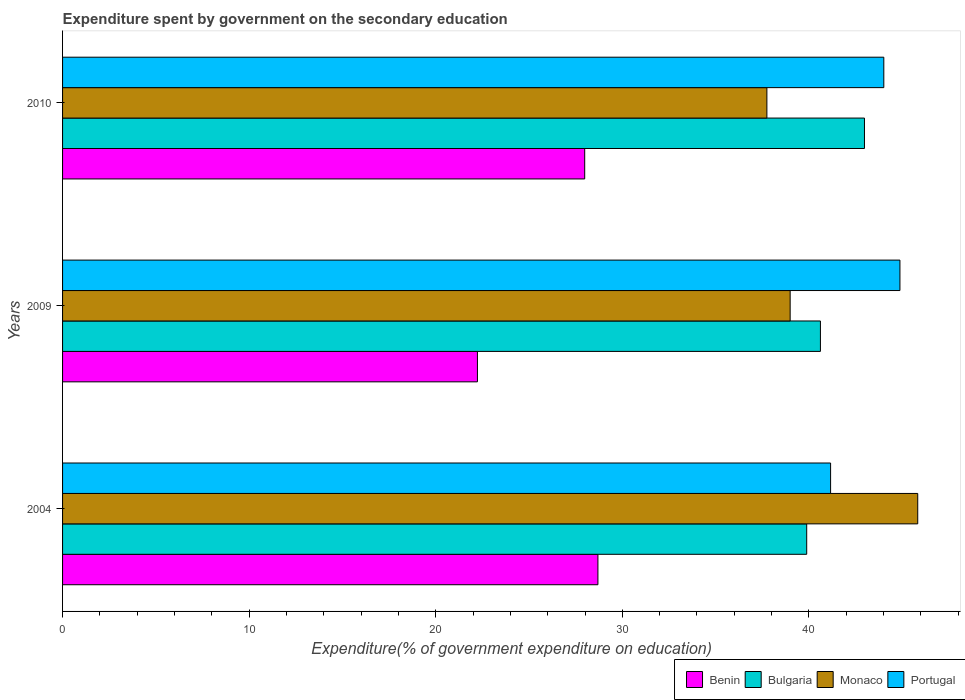How many groups of bars are there?
Your response must be concise. 3. Are the number of bars on each tick of the Y-axis equal?
Offer a terse response. Yes. How many bars are there on the 1st tick from the top?
Your answer should be compact. 4. What is the expenditure spent by government on the secondary education in Bulgaria in 2010?
Offer a terse response. 42.98. Across all years, what is the maximum expenditure spent by government on the secondary education in Bulgaria?
Your answer should be very brief. 42.98. Across all years, what is the minimum expenditure spent by government on the secondary education in Bulgaria?
Provide a succinct answer. 39.88. What is the total expenditure spent by government on the secondary education in Benin in the graph?
Offer a very short reply. 78.91. What is the difference between the expenditure spent by government on the secondary education in Monaco in 2004 and that in 2010?
Your answer should be very brief. 8.08. What is the difference between the expenditure spent by government on the secondary education in Portugal in 2010 and the expenditure spent by government on the secondary education in Bulgaria in 2009?
Your answer should be very brief. 3.4. What is the average expenditure spent by government on the secondary education in Benin per year?
Provide a short and direct response. 26.3. In the year 2009, what is the difference between the expenditure spent by government on the secondary education in Bulgaria and expenditure spent by government on the secondary education in Monaco?
Your response must be concise. 1.62. In how many years, is the expenditure spent by government on the secondary education in Benin greater than 12 %?
Make the answer very short. 3. What is the ratio of the expenditure spent by government on the secondary education in Bulgaria in 2009 to that in 2010?
Offer a terse response. 0.95. Is the expenditure spent by government on the secondary education in Portugal in 2004 less than that in 2010?
Offer a terse response. Yes. What is the difference between the highest and the second highest expenditure spent by government on the secondary education in Bulgaria?
Keep it short and to the point. 2.36. What is the difference between the highest and the lowest expenditure spent by government on the secondary education in Bulgaria?
Your answer should be very brief. 3.1. In how many years, is the expenditure spent by government on the secondary education in Benin greater than the average expenditure spent by government on the secondary education in Benin taken over all years?
Provide a short and direct response. 2. Is the sum of the expenditure spent by government on the secondary education in Bulgaria in 2004 and 2010 greater than the maximum expenditure spent by government on the secondary education in Benin across all years?
Provide a short and direct response. Yes. What does the 4th bar from the top in 2009 represents?
Offer a terse response. Benin. What does the 1st bar from the bottom in 2004 represents?
Your answer should be very brief. Benin. What is the difference between two consecutive major ticks on the X-axis?
Your answer should be compact. 10. Are the values on the major ticks of X-axis written in scientific E-notation?
Your answer should be very brief. No. Does the graph contain grids?
Make the answer very short. No. How many legend labels are there?
Keep it short and to the point. 4. How are the legend labels stacked?
Your answer should be very brief. Horizontal. What is the title of the graph?
Your answer should be compact. Expenditure spent by government on the secondary education. What is the label or title of the X-axis?
Make the answer very short. Expenditure(% of government expenditure on education). What is the Expenditure(% of government expenditure on education) of Benin in 2004?
Provide a succinct answer. 28.69. What is the Expenditure(% of government expenditure on education) in Bulgaria in 2004?
Ensure brevity in your answer.  39.88. What is the Expenditure(% of government expenditure on education) in Monaco in 2004?
Make the answer very short. 45.83. What is the Expenditure(% of government expenditure on education) of Portugal in 2004?
Your response must be concise. 41.16. What is the Expenditure(% of government expenditure on education) in Benin in 2009?
Your answer should be very brief. 22.23. What is the Expenditure(% of government expenditure on education) of Bulgaria in 2009?
Make the answer very short. 40.62. What is the Expenditure(% of government expenditure on education) of Monaco in 2009?
Provide a succinct answer. 38.99. What is the Expenditure(% of government expenditure on education) in Portugal in 2009?
Keep it short and to the point. 44.88. What is the Expenditure(% of government expenditure on education) of Benin in 2010?
Your answer should be very brief. 27.98. What is the Expenditure(% of government expenditure on education) in Bulgaria in 2010?
Your answer should be compact. 42.98. What is the Expenditure(% of government expenditure on education) in Monaco in 2010?
Offer a terse response. 37.75. What is the Expenditure(% of government expenditure on education) in Portugal in 2010?
Your answer should be very brief. 44.01. Across all years, what is the maximum Expenditure(% of government expenditure on education) of Benin?
Your answer should be compact. 28.69. Across all years, what is the maximum Expenditure(% of government expenditure on education) in Bulgaria?
Provide a short and direct response. 42.98. Across all years, what is the maximum Expenditure(% of government expenditure on education) in Monaco?
Provide a succinct answer. 45.83. Across all years, what is the maximum Expenditure(% of government expenditure on education) of Portugal?
Make the answer very short. 44.88. Across all years, what is the minimum Expenditure(% of government expenditure on education) of Benin?
Offer a very short reply. 22.23. Across all years, what is the minimum Expenditure(% of government expenditure on education) in Bulgaria?
Your answer should be very brief. 39.88. Across all years, what is the minimum Expenditure(% of government expenditure on education) of Monaco?
Keep it short and to the point. 37.75. Across all years, what is the minimum Expenditure(% of government expenditure on education) of Portugal?
Your answer should be very brief. 41.16. What is the total Expenditure(% of government expenditure on education) of Benin in the graph?
Your response must be concise. 78.91. What is the total Expenditure(% of government expenditure on education) of Bulgaria in the graph?
Ensure brevity in your answer.  123.47. What is the total Expenditure(% of government expenditure on education) in Monaco in the graph?
Provide a succinct answer. 122.57. What is the total Expenditure(% of government expenditure on education) in Portugal in the graph?
Offer a terse response. 130.05. What is the difference between the Expenditure(% of government expenditure on education) of Benin in 2004 and that in 2009?
Keep it short and to the point. 6.46. What is the difference between the Expenditure(% of government expenditure on education) in Bulgaria in 2004 and that in 2009?
Give a very brief answer. -0.74. What is the difference between the Expenditure(% of government expenditure on education) in Monaco in 2004 and that in 2009?
Keep it short and to the point. 6.84. What is the difference between the Expenditure(% of government expenditure on education) of Portugal in 2004 and that in 2009?
Your answer should be very brief. -3.72. What is the difference between the Expenditure(% of government expenditure on education) in Benin in 2004 and that in 2010?
Keep it short and to the point. 0.71. What is the difference between the Expenditure(% of government expenditure on education) of Bulgaria in 2004 and that in 2010?
Offer a terse response. -3.1. What is the difference between the Expenditure(% of government expenditure on education) of Monaco in 2004 and that in 2010?
Keep it short and to the point. 8.08. What is the difference between the Expenditure(% of government expenditure on education) in Portugal in 2004 and that in 2010?
Your response must be concise. -2.85. What is the difference between the Expenditure(% of government expenditure on education) in Benin in 2009 and that in 2010?
Your answer should be very brief. -5.75. What is the difference between the Expenditure(% of government expenditure on education) of Bulgaria in 2009 and that in 2010?
Keep it short and to the point. -2.36. What is the difference between the Expenditure(% of government expenditure on education) in Monaco in 2009 and that in 2010?
Provide a succinct answer. 1.25. What is the difference between the Expenditure(% of government expenditure on education) of Portugal in 2009 and that in 2010?
Offer a very short reply. 0.86. What is the difference between the Expenditure(% of government expenditure on education) in Benin in 2004 and the Expenditure(% of government expenditure on education) in Bulgaria in 2009?
Ensure brevity in your answer.  -11.93. What is the difference between the Expenditure(% of government expenditure on education) in Benin in 2004 and the Expenditure(% of government expenditure on education) in Monaco in 2009?
Give a very brief answer. -10.3. What is the difference between the Expenditure(% of government expenditure on education) in Benin in 2004 and the Expenditure(% of government expenditure on education) in Portugal in 2009?
Offer a terse response. -16.19. What is the difference between the Expenditure(% of government expenditure on education) in Bulgaria in 2004 and the Expenditure(% of government expenditure on education) in Monaco in 2009?
Make the answer very short. 0.89. What is the difference between the Expenditure(% of government expenditure on education) in Bulgaria in 2004 and the Expenditure(% of government expenditure on education) in Portugal in 2009?
Make the answer very short. -5. What is the difference between the Expenditure(% of government expenditure on education) of Monaco in 2004 and the Expenditure(% of government expenditure on education) of Portugal in 2009?
Make the answer very short. 0.95. What is the difference between the Expenditure(% of government expenditure on education) in Benin in 2004 and the Expenditure(% of government expenditure on education) in Bulgaria in 2010?
Make the answer very short. -14.29. What is the difference between the Expenditure(% of government expenditure on education) of Benin in 2004 and the Expenditure(% of government expenditure on education) of Monaco in 2010?
Ensure brevity in your answer.  -9.06. What is the difference between the Expenditure(% of government expenditure on education) of Benin in 2004 and the Expenditure(% of government expenditure on education) of Portugal in 2010?
Ensure brevity in your answer.  -15.32. What is the difference between the Expenditure(% of government expenditure on education) in Bulgaria in 2004 and the Expenditure(% of government expenditure on education) in Monaco in 2010?
Offer a very short reply. 2.13. What is the difference between the Expenditure(% of government expenditure on education) in Bulgaria in 2004 and the Expenditure(% of government expenditure on education) in Portugal in 2010?
Your answer should be very brief. -4.13. What is the difference between the Expenditure(% of government expenditure on education) of Monaco in 2004 and the Expenditure(% of government expenditure on education) of Portugal in 2010?
Your answer should be very brief. 1.82. What is the difference between the Expenditure(% of government expenditure on education) in Benin in 2009 and the Expenditure(% of government expenditure on education) in Bulgaria in 2010?
Provide a succinct answer. -20.74. What is the difference between the Expenditure(% of government expenditure on education) in Benin in 2009 and the Expenditure(% of government expenditure on education) in Monaco in 2010?
Offer a terse response. -15.51. What is the difference between the Expenditure(% of government expenditure on education) in Benin in 2009 and the Expenditure(% of government expenditure on education) in Portugal in 2010?
Offer a very short reply. -21.78. What is the difference between the Expenditure(% of government expenditure on education) in Bulgaria in 2009 and the Expenditure(% of government expenditure on education) in Monaco in 2010?
Provide a short and direct response. 2.87. What is the difference between the Expenditure(% of government expenditure on education) of Bulgaria in 2009 and the Expenditure(% of government expenditure on education) of Portugal in 2010?
Your response must be concise. -3.4. What is the difference between the Expenditure(% of government expenditure on education) in Monaco in 2009 and the Expenditure(% of government expenditure on education) in Portugal in 2010?
Your response must be concise. -5.02. What is the average Expenditure(% of government expenditure on education) in Benin per year?
Make the answer very short. 26.3. What is the average Expenditure(% of government expenditure on education) of Bulgaria per year?
Make the answer very short. 41.16. What is the average Expenditure(% of government expenditure on education) of Monaco per year?
Offer a terse response. 40.86. What is the average Expenditure(% of government expenditure on education) of Portugal per year?
Your answer should be compact. 43.35. In the year 2004, what is the difference between the Expenditure(% of government expenditure on education) of Benin and Expenditure(% of government expenditure on education) of Bulgaria?
Ensure brevity in your answer.  -11.19. In the year 2004, what is the difference between the Expenditure(% of government expenditure on education) in Benin and Expenditure(% of government expenditure on education) in Monaco?
Give a very brief answer. -17.14. In the year 2004, what is the difference between the Expenditure(% of government expenditure on education) of Benin and Expenditure(% of government expenditure on education) of Portugal?
Offer a terse response. -12.47. In the year 2004, what is the difference between the Expenditure(% of government expenditure on education) of Bulgaria and Expenditure(% of government expenditure on education) of Monaco?
Provide a short and direct response. -5.95. In the year 2004, what is the difference between the Expenditure(% of government expenditure on education) in Bulgaria and Expenditure(% of government expenditure on education) in Portugal?
Offer a terse response. -1.28. In the year 2004, what is the difference between the Expenditure(% of government expenditure on education) of Monaco and Expenditure(% of government expenditure on education) of Portugal?
Make the answer very short. 4.67. In the year 2009, what is the difference between the Expenditure(% of government expenditure on education) in Benin and Expenditure(% of government expenditure on education) in Bulgaria?
Give a very brief answer. -18.38. In the year 2009, what is the difference between the Expenditure(% of government expenditure on education) of Benin and Expenditure(% of government expenditure on education) of Monaco?
Make the answer very short. -16.76. In the year 2009, what is the difference between the Expenditure(% of government expenditure on education) of Benin and Expenditure(% of government expenditure on education) of Portugal?
Ensure brevity in your answer.  -22.64. In the year 2009, what is the difference between the Expenditure(% of government expenditure on education) in Bulgaria and Expenditure(% of government expenditure on education) in Monaco?
Keep it short and to the point. 1.62. In the year 2009, what is the difference between the Expenditure(% of government expenditure on education) in Bulgaria and Expenditure(% of government expenditure on education) in Portugal?
Give a very brief answer. -4.26. In the year 2009, what is the difference between the Expenditure(% of government expenditure on education) in Monaco and Expenditure(% of government expenditure on education) in Portugal?
Offer a very short reply. -5.88. In the year 2010, what is the difference between the Expenditure(% of government expenditure on education) of Benin and Expenditure(% of government expenditure on education) of Bulgaria?
Your answer should be very brief. -14.99. In the year 2010, what is the difference between the Expenditure(% of government expenditure on education) in Benin and Expenditure(% of government expenditure on education) in Monaco?
Provide a short and direct response. -9.76. In the year 2010, what is the difference between the Expenditure(% of government expenditure on education) in Benin and Expenditure(% of government expenditure on education) in Portugal?
Offer a terse response. -16.03. In the year 2010, what is the difference between the Expenditure(% of government expenditure on education) of Bulgaria and Expenditure(% of government expenditure on education) of Monaco?
Ensure brevity in your answer.  5.23. In the year 2010, what is the difference between the Expenditure(% of government expenditure on education) in Bulgaria and Expenditure(% of government expenditure on education) in Portugal?
Offer a very short reply. -1.04. In the year 2010, what is the difference between the Expenditure(% of government expenditure on education) of Monaco and Expenditure(% of government expenditure on education) of Portugal?
Make the answer very short. -6.27. What is the ratio of the Expenditure(% of government expenditure on education) of Benin in 2004 to that in 2009?
Provide a short and direct response. 1.29. What is the ratio of the Expenditure(% of government expenditure on education) of Bulgaria in 2004 to that in 2009?
Make the answer very short. 0.98. What is the ratio of the Expenditure(% of government expenditure on education) in Monaco in 2004 to that in 2009?
Offer a terse response. 1.18. What is the ratio of the Expenditure(% of government expenditure on education) in Portugal in 2004 to that in 2009?
Your response must be concise. 0.92. What is the ratio of the Expenditure(% of government expenditure on education) of Benin in 2004 to that in 2010?
Make the answer very short. 1.03. What is the ratio of the Expenditure(% of government expenditure on education) of Bulgaria in 2004 to that in 2010?
Your response must be concise. 0.93. What is the ratio of the Expenditure(% of government expenditure on education) of Monaco in 2004 to that in 2010?
Give a very brief answer. 1.21. What is the ratio of the Expenditure(% of government expenditure on education) in Portugal in 2004 to that in 2010?
Give a very brief answer. 0.94. What is the ratio of the Expenditure(% of government expenditure on education) in Benin in 2009 to that in 2010?
Provide a short and direct response. 0.79. What is the ratio of the Expenditure(% of government expenditure on education) of Bulgaria in 2009 to that in 2010?
Ensure brevity in your answer.  0.95. What is the ratio of the Expenditure(% of government expenditure on education) of Monaco in 2009 to that in 2010?
Your response must be concise. 1.03. What is the ratio of the Expenditure(% of government expenditure on education) in Portugal in 2009 to that in 2010?
Ensure brevity in your answer.  1.02. What is the difference between the highest and the second highest Expenditure(% of government expenditure on education) of Benin?
Your answer should be very brief. 0.71. What is the difference between the highest and the second highest Expenditure(% of government expenditure on education) in Bulgaria?
Keep it short and to the point. 2.36. What is the difference between the highest and the second highest Expenditure(% of government expenditure on education) in Monaco?
Make the answer very short. 6.84. What is the difference between the highest and the second highest Expenditure(% of government expenditure on education) of Portugal?
Provide a short and direct response. 0.86. What is the difference between the highest and the lowest Expenditure(% of government expenditure on education) of Benin?
Your answer should be compact. 6.46. What is the difference between the highest and the lowest Expenditure(% of government expenditure on education) of Bulgaria?
Give a very brief answer. 3.1. What is the difference between the highest and the lowest Expenditure(% of government expenditure on education) in Monaco?
Your answer should be very brief. 8.08. What is the difference between the highest and the lowest Expenditure(% of government expenditure on education) in Portugal?
Offer a very short reply. 3.72. 